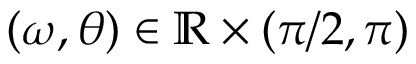Convert formula to latex. <formula><loc_0><loc_0><loc_500><loc_500>( \omega , \theta ) \in \mathbb { R } \times ( \pi / 2 , \pi )</formula> 